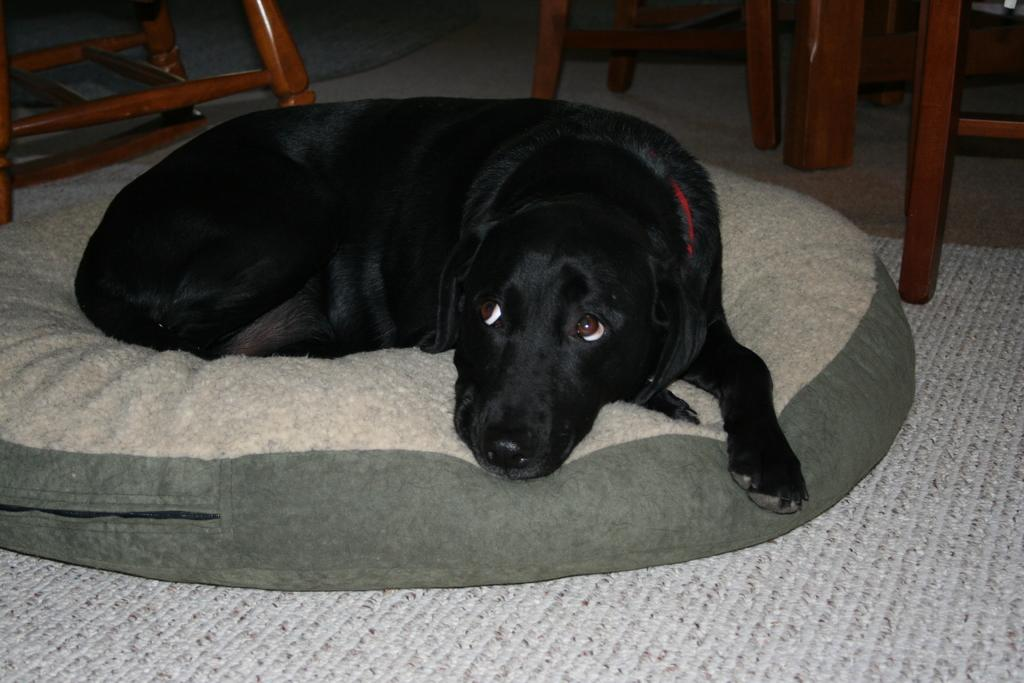What type of animal is in the image? There is a black dog in the image. Where is the dog located in the image? The dog is sleeping on a sofa. What type of furniture is visible in the image besides the sofa? There are chairs with visible legs in the image. What type of bedding is present in the image? There is a mattress in the image. What impulse did the dog have to jump on the sofa in the image? The provided facts do not mention any impulse or action taken by the dog; it is simply sleeping on the sofa. 